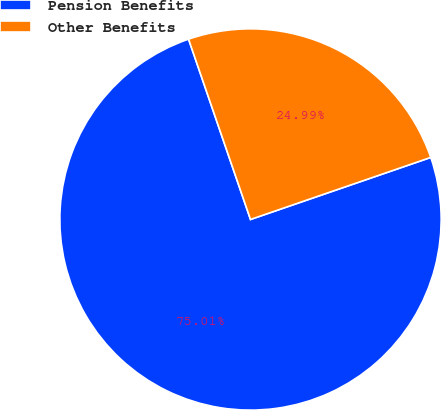Convert chart. <chart><loc_0><loc_0><loc_500><loc_500><pie_chart><fcel>Pension Benefits<fcel>Other Benefits<nl><fcel>75.01%<fcel>24.99%<nl></chart> 